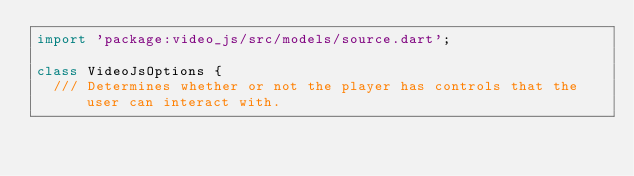<code> <loc_0><loc_0><loc_500><loc_500><_Dart_>import 'package:video_js/src/models/source.dart';

class VideoJsOptions {
  /// Determines whether or not the player has controls that the user can interact with.</code> 